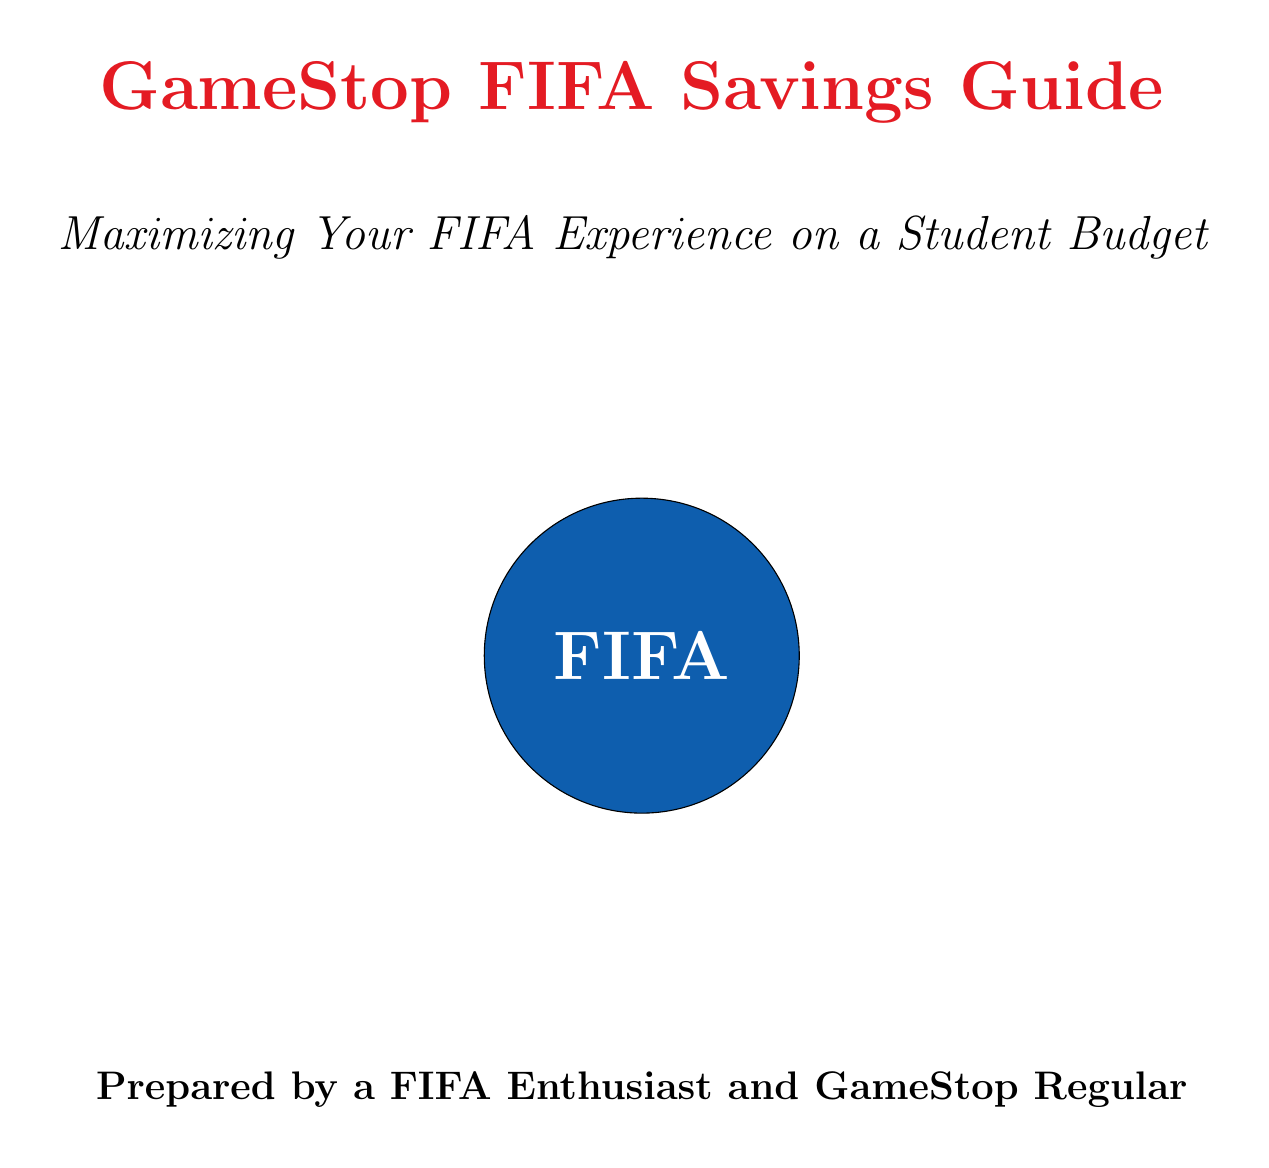What is the name of the loyalty program mentioned? The loyalty program mentioned in the document is clearly stated as "PowerUp Rewards."
Answer: PowerUp Rewards What benefit do Pro members receive each month? The document specifies that Pro members receive a "Monthly $5 reward certificate."
Answer: Monthly $5 reward certificate What is the advantage of the Trade-In Bonus promotion? The document indicates that the Trade-In Bonus offers "extra credit when trading in games towards FIFA 23."
Answer: Extra credit when trading in games towards FIFA 23 What recommendation is given regarding the purchase frequency for FIFA? The document suggests considering "annual vs. bi-annual purchases" for potential savings.
Answer: Annual vs. bi-annual purchases What seasonal events should students look for sales? The document lists "Black Friday, holiday, and end-of-season sales" as key events for discounts.
Answer: Black Friday, holiday, and end-of-season sales What is one strategy to save on FIFA purchases digitally? The document recommends comparing prices between digital and physical copies of FIFA games.
Answer: Compare prices between digital and physical copies How can GameStop employees assist with gaming purchases? One way is that employees often "know about future deals before they're publicly announced."
Answer: Know about future deals What alternatives to FIFA Ultimate Team are suggested? The document suggests exploring "Career Mode or Pro Clubs" as alternatives.
Answer: Career Mode or Pro Clubs 